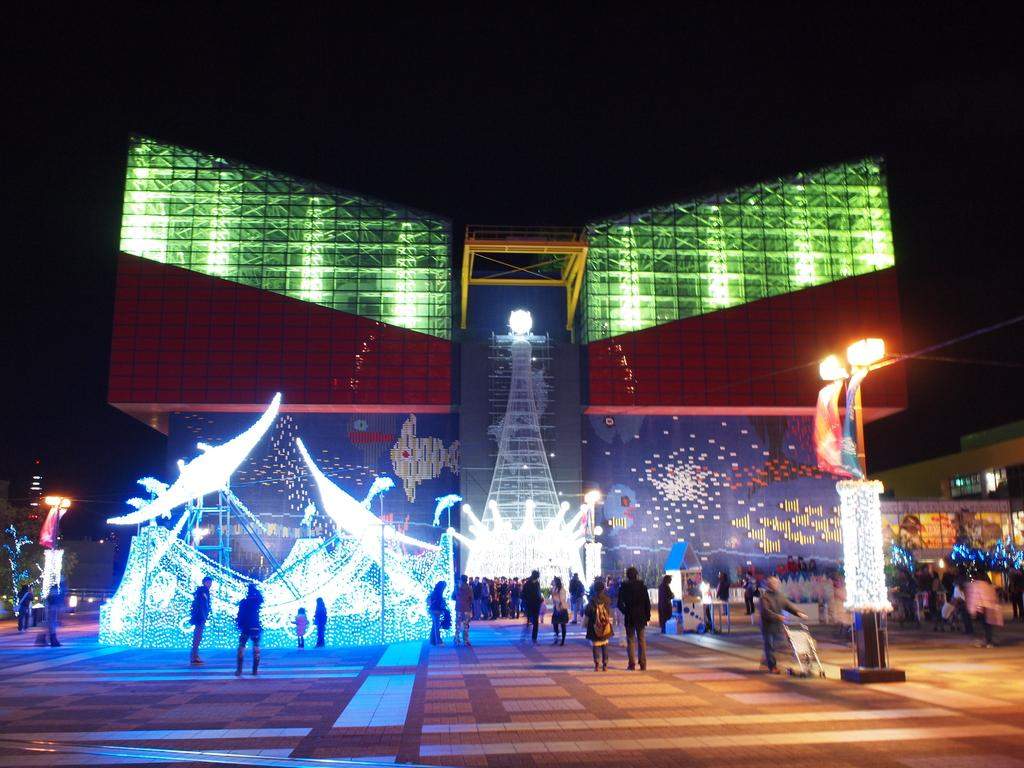How many people are present in the image? There are many people in the image. What can be seen in the front of the image? There is a light pole with decorations in the front of the image. What is visible in the background of the image? There are buildings with light decorations in the background of the image. What type of wax is being distributed to the animals in the zoo in the image? There is no zoo or wax present in the image. 